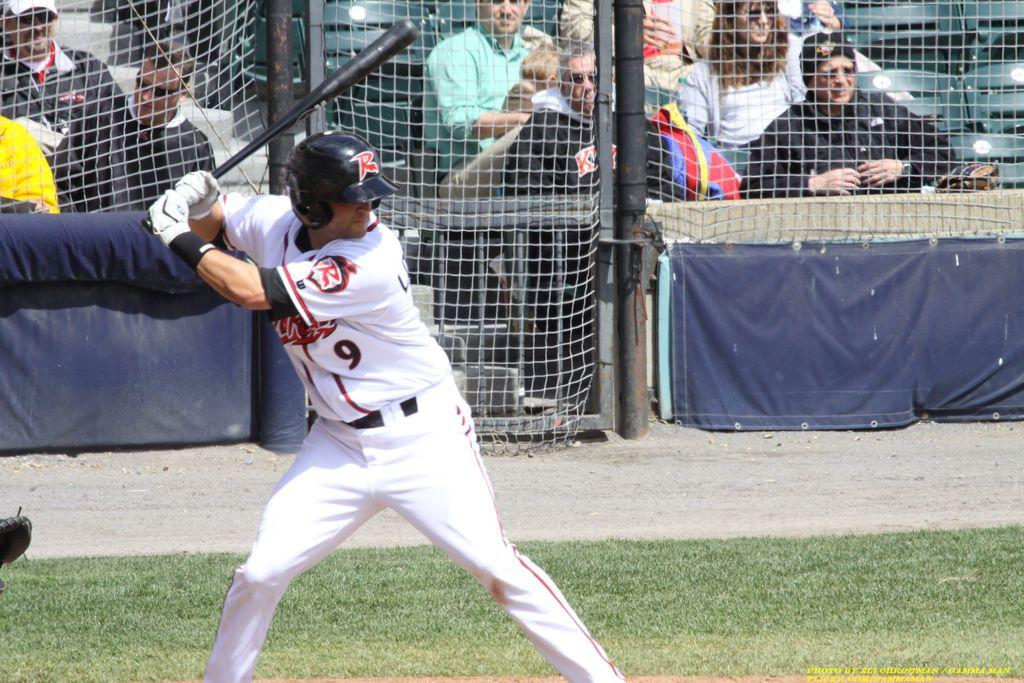<image>
Present a compact description of the photo's key features. A man wearing a number 9 on his jersey getting ready to bat. 